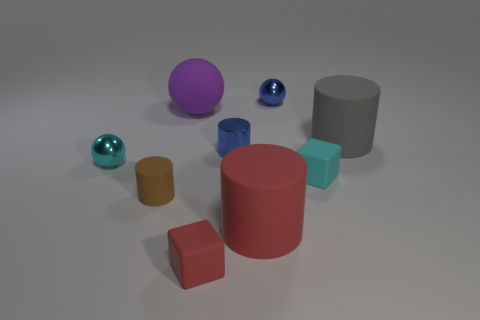There is a matte cylinder left of the tiny blue cylinder; is there a small metallic object on the left side of it?
Your answer should be compact. Yes. Do the cyan metallic sphere and the cyan matte object have the same size?
Your answer should be very brief. Yes. What is the brown object on the left side of the ball behind the large rubber object that is left of the large red cylinder made of?
Provide a short and direct response. Rubber. Are there the same number of tiny blue shiny things in front of the purple rubber object and cyan matte blocks?
Offer a very short reply. Yes. How many things are small red objects or matte cylinders?
Offer a terse response. 4. What is the shape of the cyan object that is the same material as the tiny blue cylinder?
Offer a terse response. Sphere. What size is the cylinder to the right of the cylinder in front of the brown rubber object?
Your answer should be compact. Large. What number of tiny objects are either blue metallic spheres or purple objects?
Provide a short and direct response. 1. How many other things are the same color as the rubber sphere?
Offer a very short reply. 0. Does the blue thing that is left of the large red rubber cylinder have the same size as the cyan thing on the right side of the large rubber sphere?
Keep it short and to the point. Yes. 